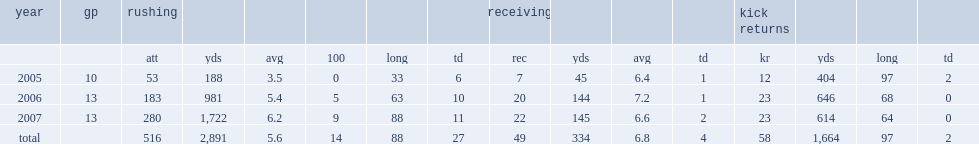In the 2007 season, how many rushing yards did jonathan stewart finish with? 1722.0. In the 2007 season, how many rushing touchdowns did jonathan stewart finish with? 11.0. In the 2007 season, how many receptions did jonathan stewart finish with? 22.0. In the 2007 season, how many receiving yards did jonathan stewart finish with? 145.0. In the 2007 season, how many receving touchdowns did jonathan stewart finish with? 2.0. 